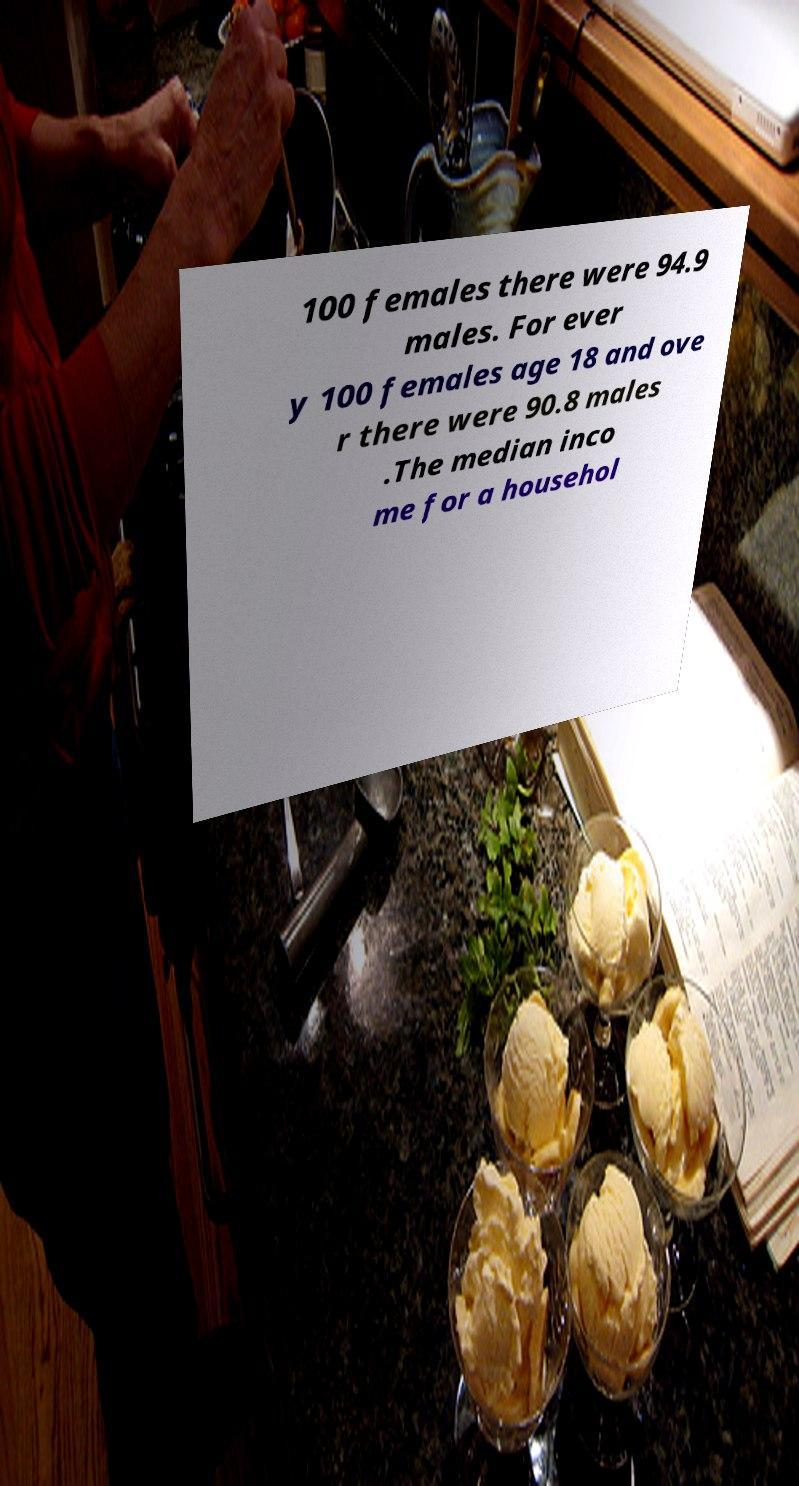For documentation purposes, I need the text within this image transcribed. Could you provide that? 100 females there were 94.9 males. For ever y 100 females age 18 and ove r there were 90.8 males .The median inco me for a househol 